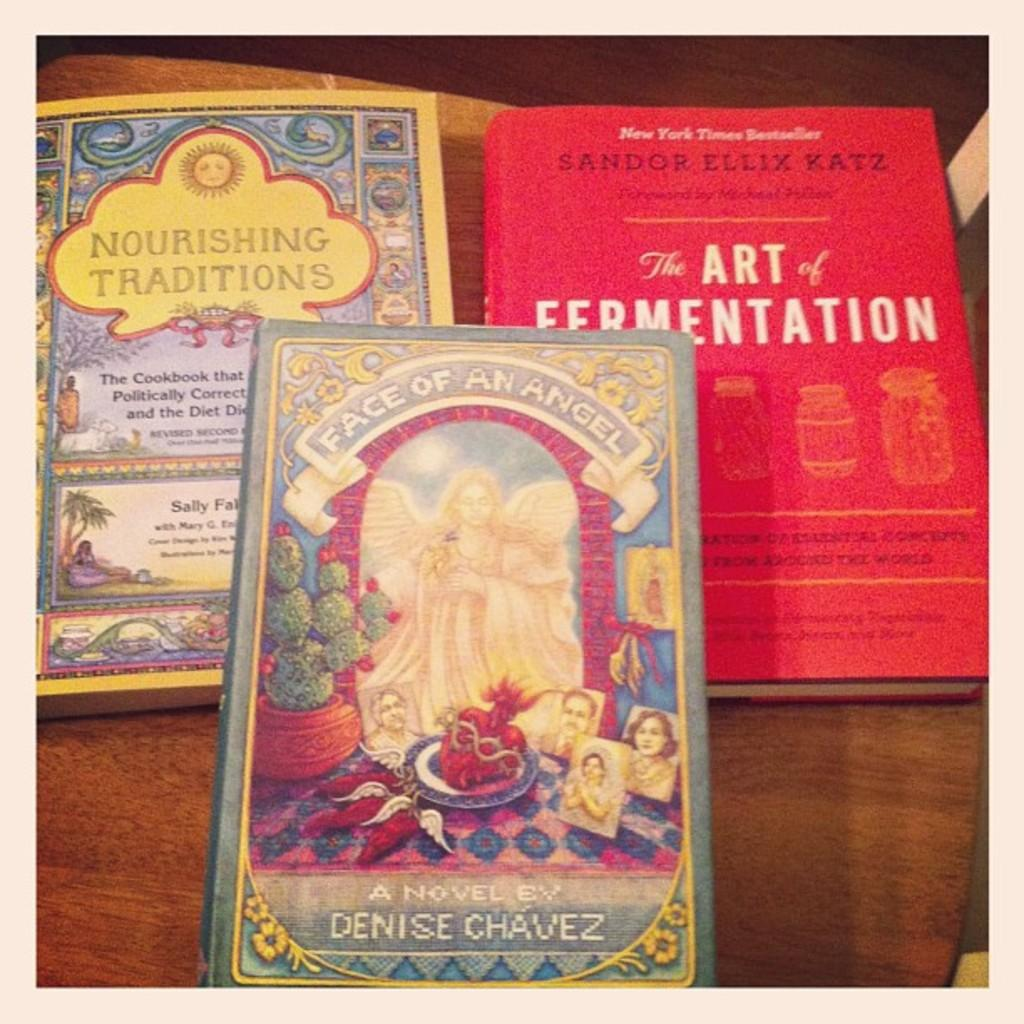<image>
Describe the image concisely. The Art of Fermentation sits on a table with two other books. 